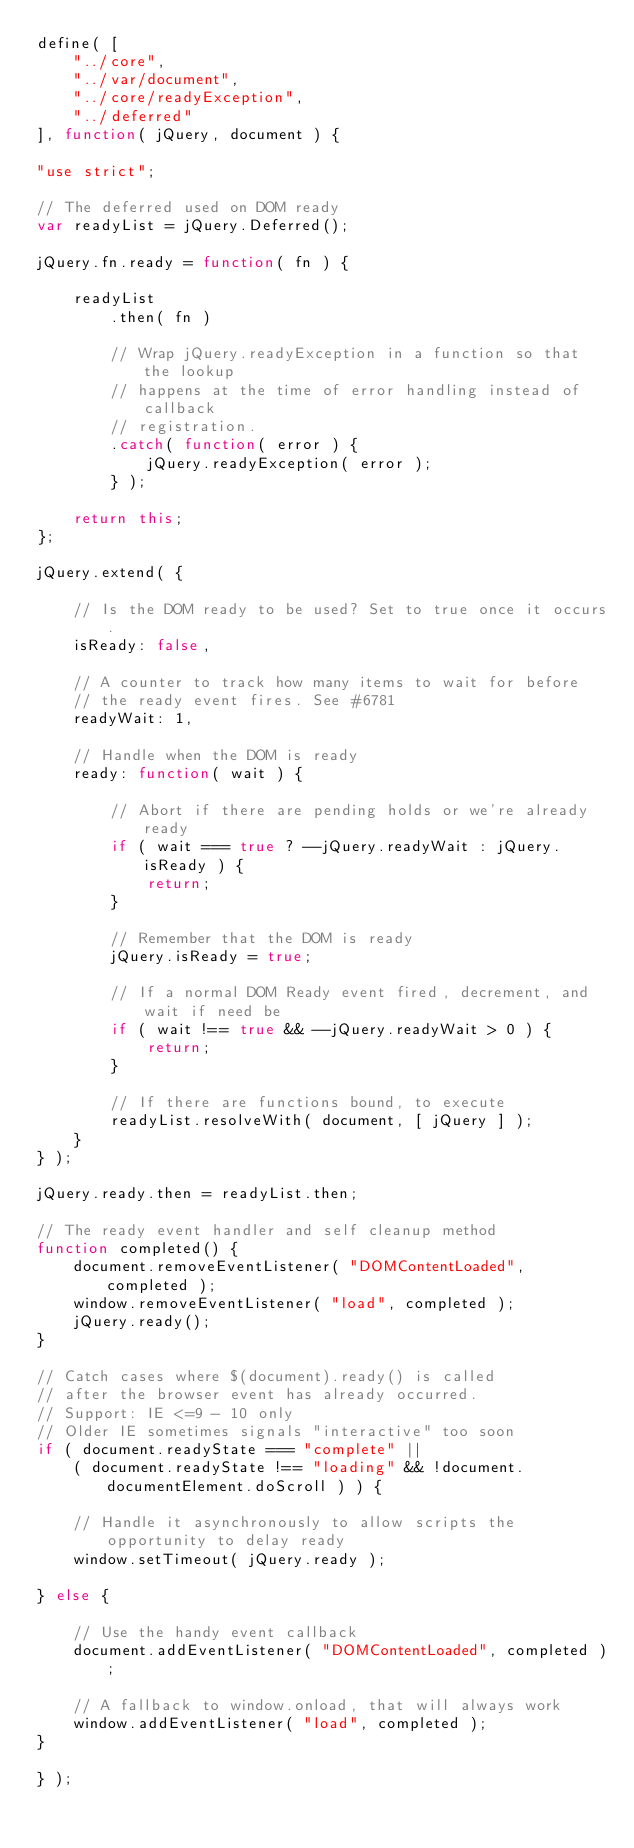<code> <loc_0><loc_0><loc_500><loc_500><_JavaScript_>define( [
	"../core",
	"../var/document",
	"../core/readyException",
	"../deferred"
], function( jQuery, document ) {

"use strict";

// The deferred used on DOM ready
var readyList = jQuery.Deferred();

jQuery.fn.ready = function( fn ) {

	readyList
		.then( fn )

		// Wrap jQuery.readyException in a function so that the lookup
		// happens at the time of error handling instead of callback
		// registration.
		.catch( function( error ) {
			jQuery.readyException( error );
		} );

	return this;
};

jQuery.extend( {

	// Is the DOM ready to be used? Set to true once it occurs.
	isReady: false,

	// A counter to track how many items to wait for before
	// the ready event fires. See #6781
	readyWait: 1,

	// Handle when the DOM is ready
	ready: function( wait ) {

		// Abort if there are pending holds or we're already ready
		if ( wait === true ? --jQuery.readyWait : jQuery.isReady ) {
			return;
		}

		// Remember that the DOM is ready
		jQuery.isReady = true;

		// If a normal DOM Ready event fired, decrement, and wait if need be
		if ( wait !== true && --jQuery.readyWait > 0 ) {
			return;
		}

		// If there are functions bound, to execute
		readyList.resolveWith( document, [ jQuery ] );
	}
} );

jQuery.ready.then = readyList.then;

// The ready event handler and self cleanup method
function completed() {
	document.removeEventListener( "DOMContentLoaded", completed );
	window.removeEventListener( "load", completed );
	jQuery.ready();
}

// Catch cases where $(document).ready() is called
// after the browser event has already occurred.
// Support: IE <=9 - 10 only
// Older IE sometimes signals "interactive" too soon
if ( document.readyState === "complete" ||
	( document.readyState !== "loading" && !document.documentElement.doScroll ) ) {

	// Handle it asynchronously to allow scripts the opportunity to delay ready
	window.setTimeout( jQuery.ready );

} else {

	// Use the handy event callback
	document.addEventListener( "DOMContentLoaded", completed );

	// A fallback to window.onload, that will always work
	window.addEventListener( "load", completed );
}

} );
</code> 